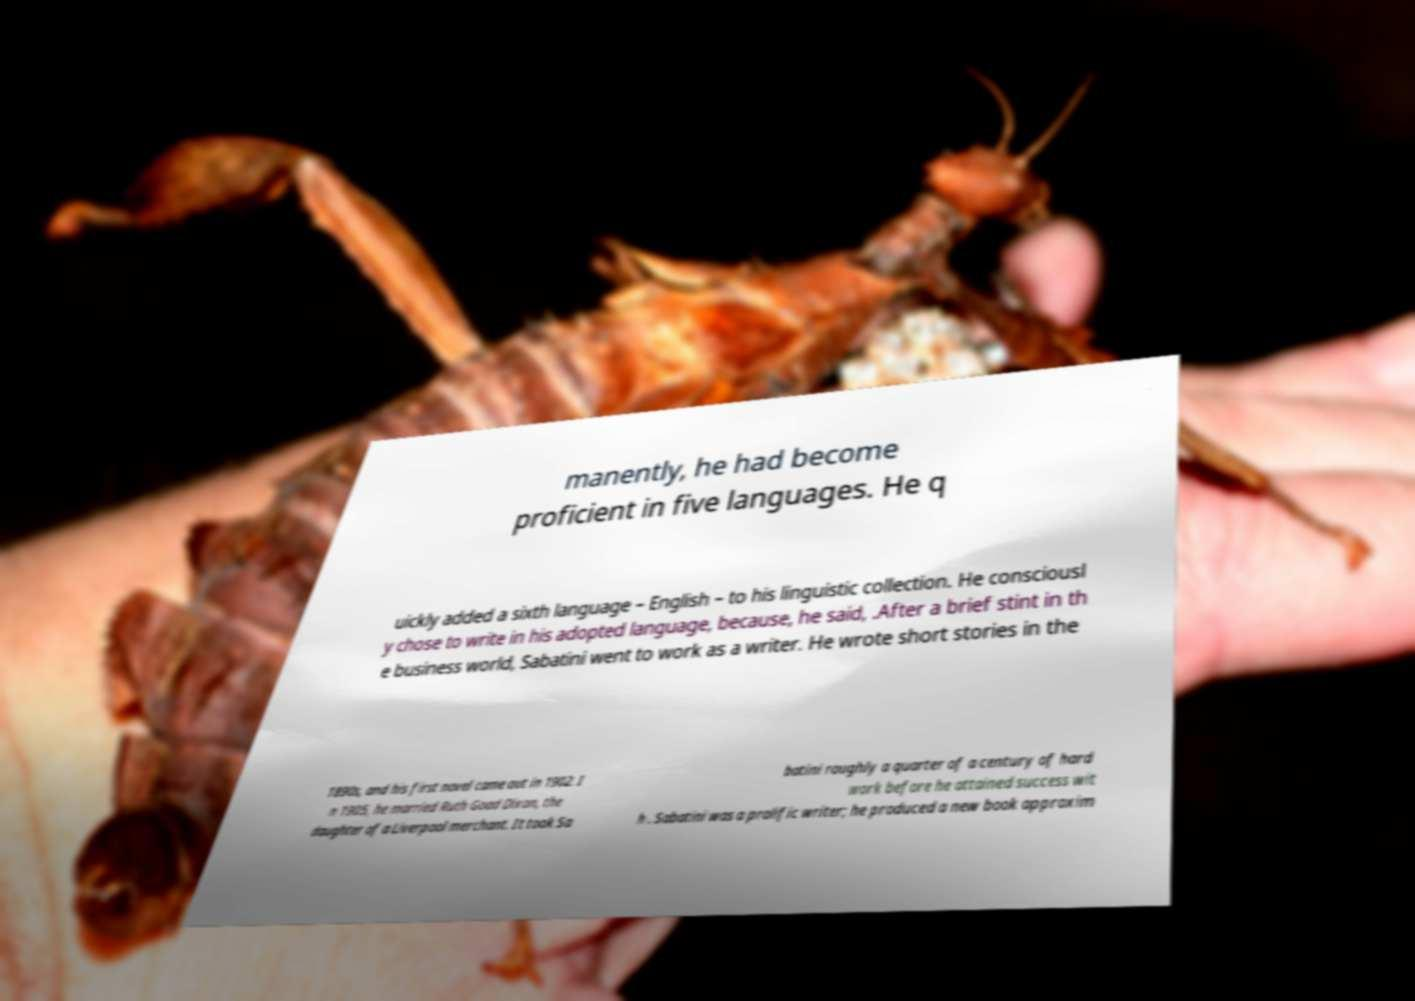Please identify and transcribe the text found in this image. manently, he had become proficient in five languages. He q uickly added a sixth language – English – to his linguistic collection. He consciousl y chose to write in his adopted language, because, he said, .After a brief stint in th e business world, Sabatini went to work as a writer. He wrote short stories in the 1890s, and his first novel came out in 1902. I n 1905, he married Ruth Goad Dixon, the daughter of a Liverpool merchant. It took Sa batini roughly a quarter of a century of hard work before he attained success wit h . Sabatini was a prolific writer; he produced a new book approxim 